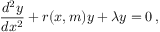<formula> <loc_0><loc_0><loc_500><loc_500>\frac { d ^ { 2 } y } { d x ^ { 2 } } + r ( x , m ) y + \lambda y = 0 \, ,</formula> 